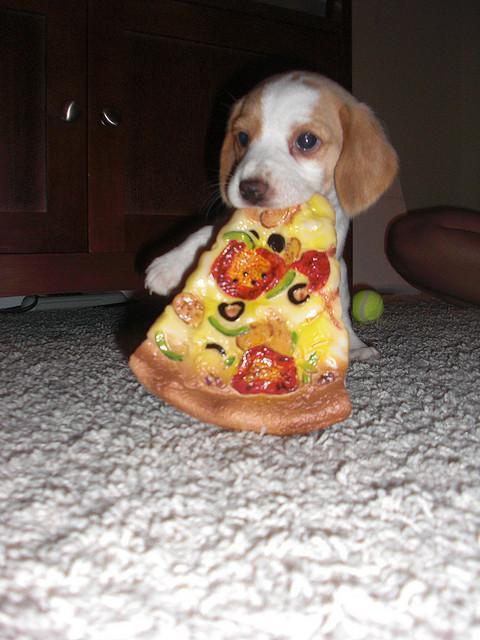Is "The pizza is below the person." an appropriate description for the image?
Answer yes or no. No. 